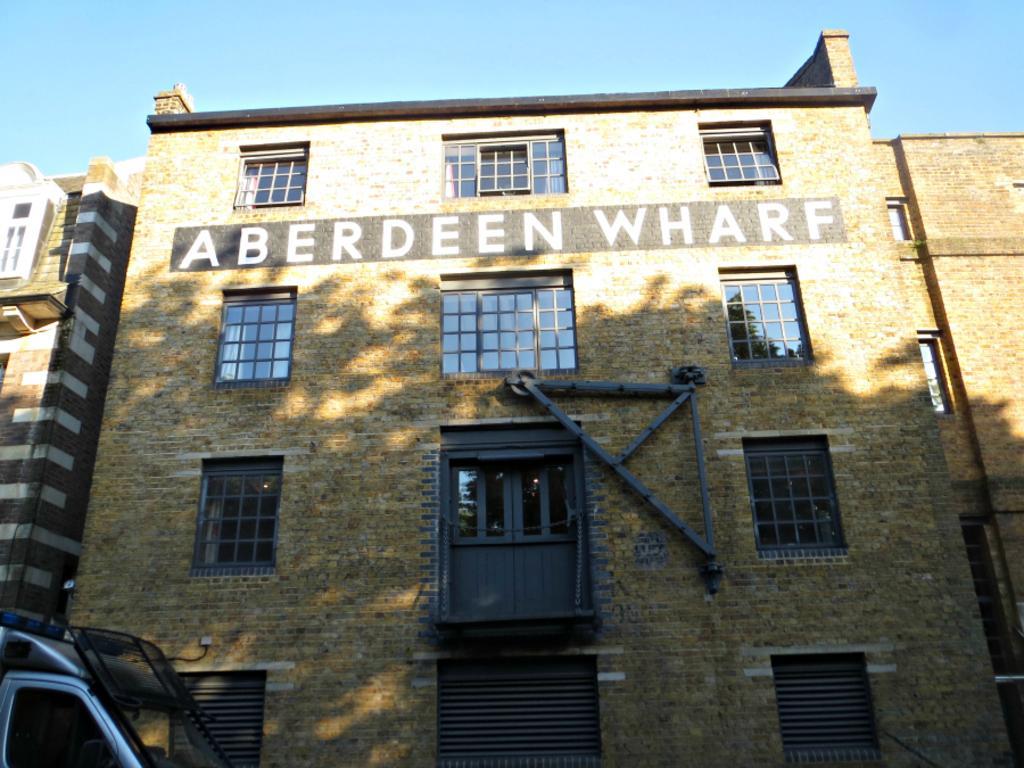In one or two sentences, can you explain what this image depicts? In this image we can see a building, windows, sky and a motor vehicle. 